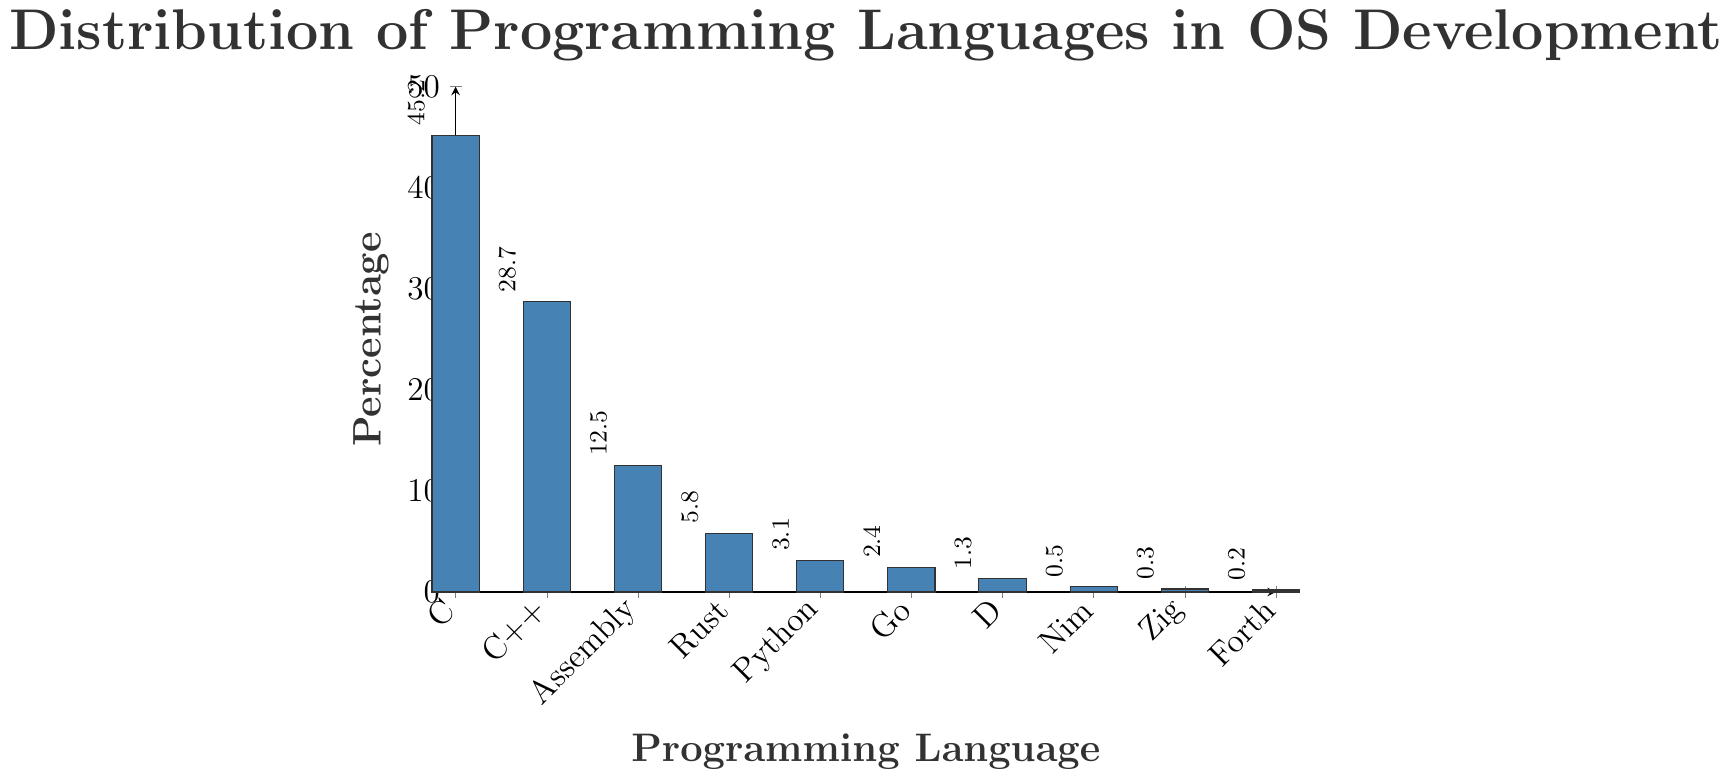what is the most used programming language in OS development? The tallest bar in the bar chart represents the highest percentage, which is for the C programming language.
Answer: C Which programming language has the lowest usage percentage in OS development? The shortest bar on the rightmost side of the chart corresponds to the language with the lowest usage percentage, which is Forth.
Answer: Forth How much more percentage does C have over C++? The percentage for C is 45.2% and for C++ is 28.7%. The difference can be calculated as 45.2 - 28.7 = 16.5.
Answer: 16.5 How many languages have a usage percentage less than 5%? The bars representing Rust (5.8%), Python (3.1%), Go (2.4%), D (1.3%), Nim (0.5%), Zig (0.3%), and Forth (0.2%) are less than 5%. Count these bars (Python, Go, D, Nim, Zig, Forth) and sum them to get the total number.
Answer: 6 What is the average percentage usage of Rust, Python, and Go? The percentages for Rust, Python, and Go are 5.8%, 3.1%, and 2.4%, respectively. Sum them up: 5.8 + 3.1 + 2.4 = 11.3. Divide by 3 to get the average: 11.3 / 3 = 3.77.
Answer: 3.77 By how much does the usage of Assembly exceed that of Go? The percentage usage of Assembly is 12.5%, and for Go, it is 2.4%. The difference can be calculated as 12.5 - 2.4 = 10.1
Answer: 10.1 What is the combined usage percentage of C, C++, and Assembly? Sum the percentages for C (45.2%), C++ (28.7%), and Assembly (12.5%) to get the combined usage: 45.2 + 28.7 + 12.5 = 86.4.
Answer: 86.4 Which languages have a usage percentage between 1% and 4%? The bars representing Python (3.1%) and Go (2.4%) fall in the range between 1% and 4%.
Answer: Python, Go What is the median value of usage percentages listed in the chart? The ordered list of percentages is 0.2, 0.3, 0.5, 1.3, 2.4, 3.1, 5.8, 12.5, 28.7, 45.2. The median is the middle value, which is the sixth value in this case, as there are 10 values. Therefore, the median is 3.1.
Answer: 3.1 Compare the combined usage percentage of Rust, Python, and Go to that of Assembly. Which is higher, and by how much? The combined percentage of Rust, Python, and Go is 5.8 + 3.1 + 2.4 = 11.3. The percentage for Assembly is 12.5%. The difference is 12.5 - 11.3 = 1.2. Assembly has a higher combined percentage by 1.2%.
Answer: Assembly by 1.2 